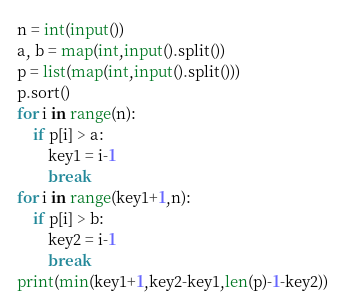<code> <loc_0><loc_0><loc_500><loc_500><_Python_>n = int(input())
a, b = map(int,input().split())
p = list(map(int,input().split()))
p.sort()
for i in range(n):
    if p[i] > a:
        key1 = i-1
        break
for i in range(key1+1,n):
    if p[i] > b:
        key2 = i-1
        break
print(min(key1+1,key2-key1,len(p)-1-key2))</code> 